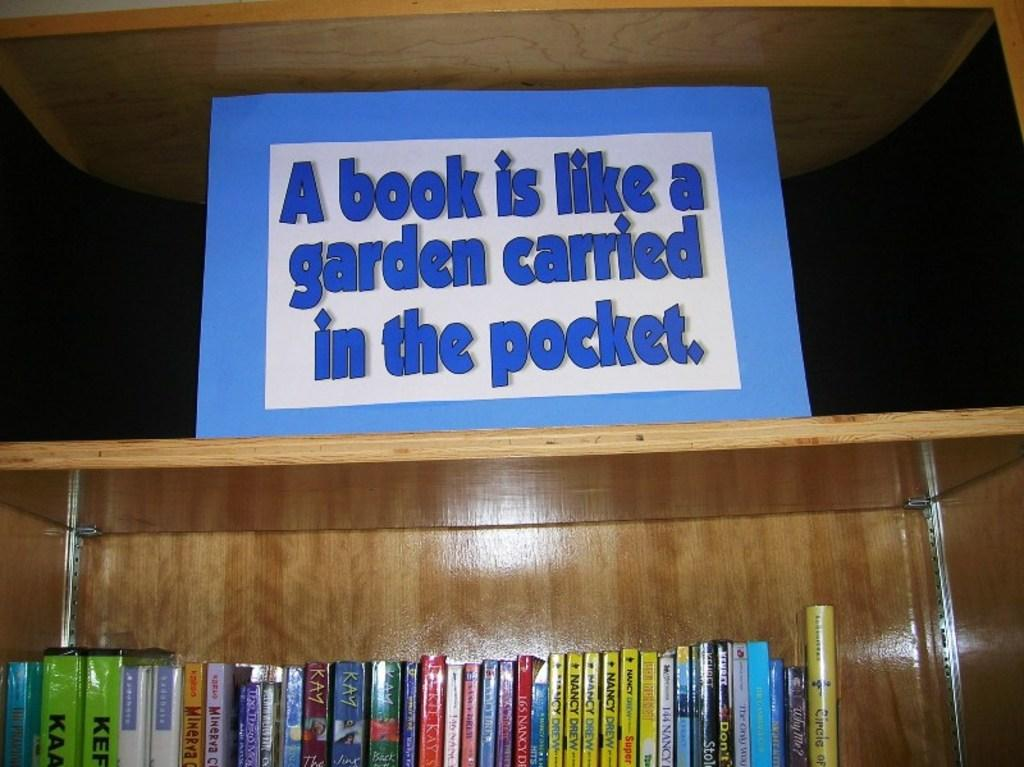<image>
Describe the image concisely. A sign that says "a book is like a garden carried in the pocket" sits on top of a bookshelf. 